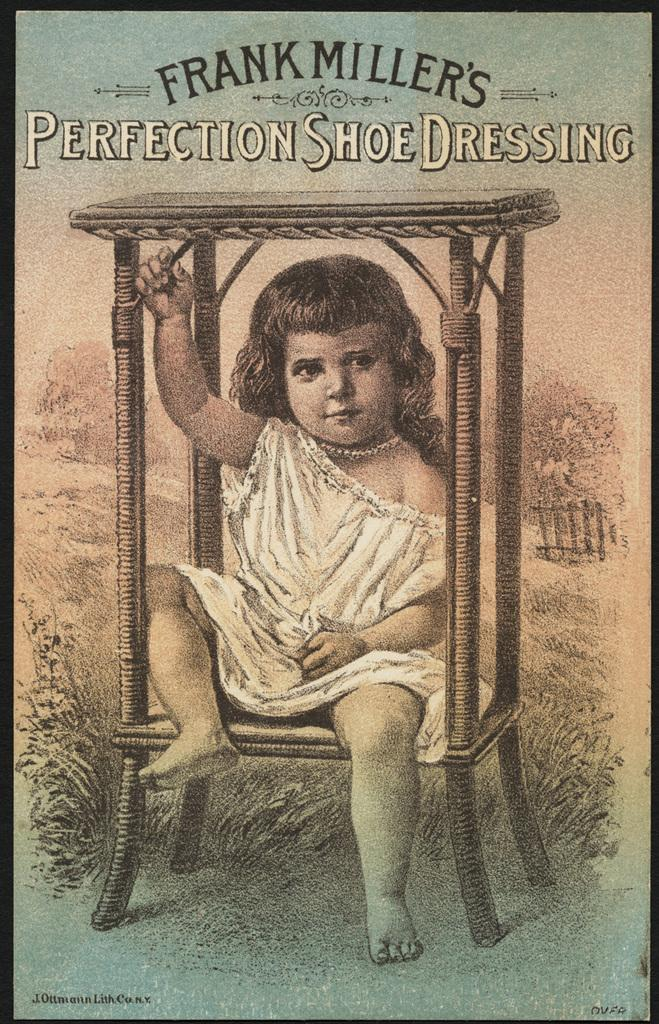<image>
Create a compact narrative representing the image presented. Frank Miller's "Perfection Shoe Dressing" features a small girl in a chair. 